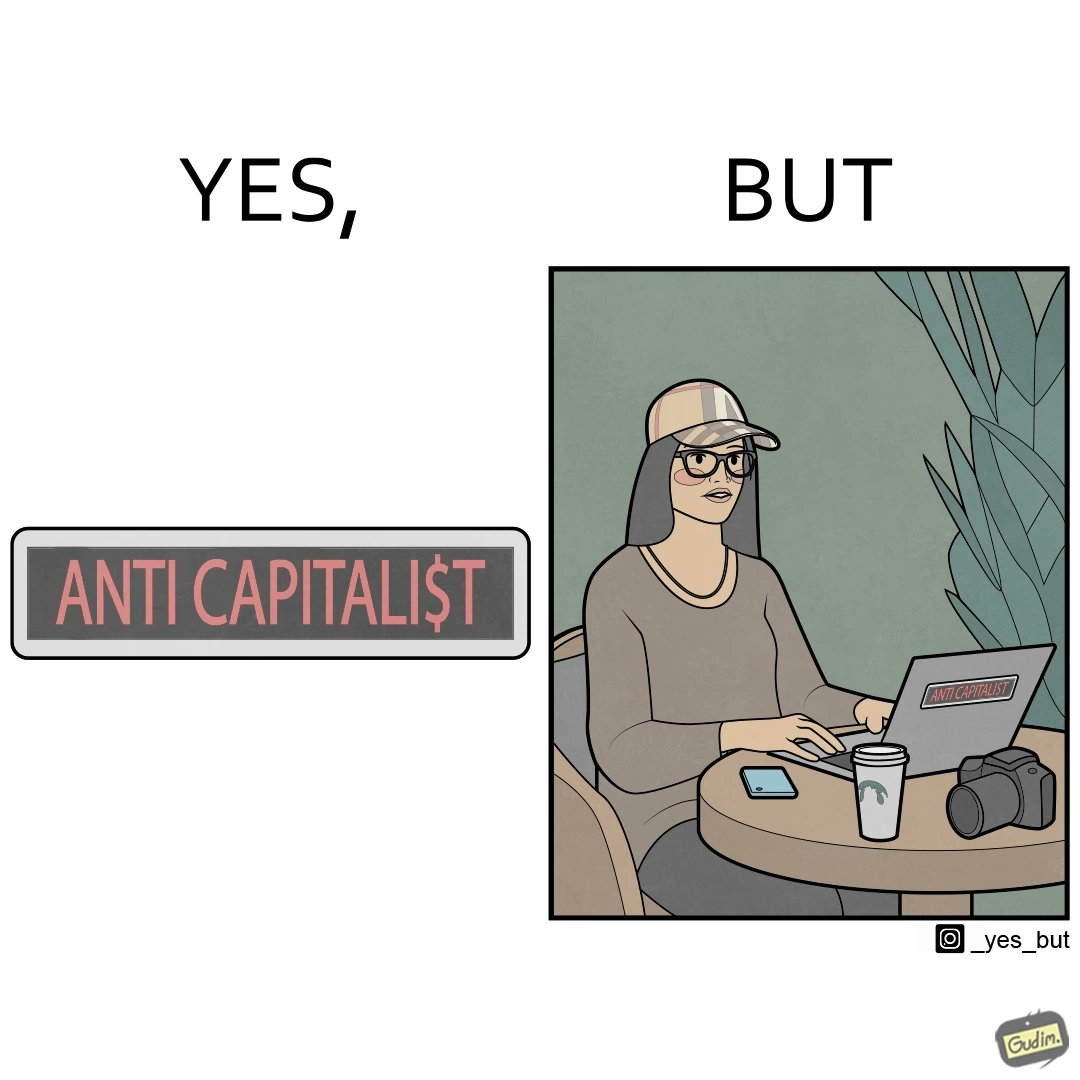What does this image depict? The overall image is ironical because the people who claim to be anticapitalist are the ones with a lot of capital as shown here. While the woman supports anticapitalism as shown by the sticker on the back of her laptop, she has a phone, a camera and a laptop all of which require money. 